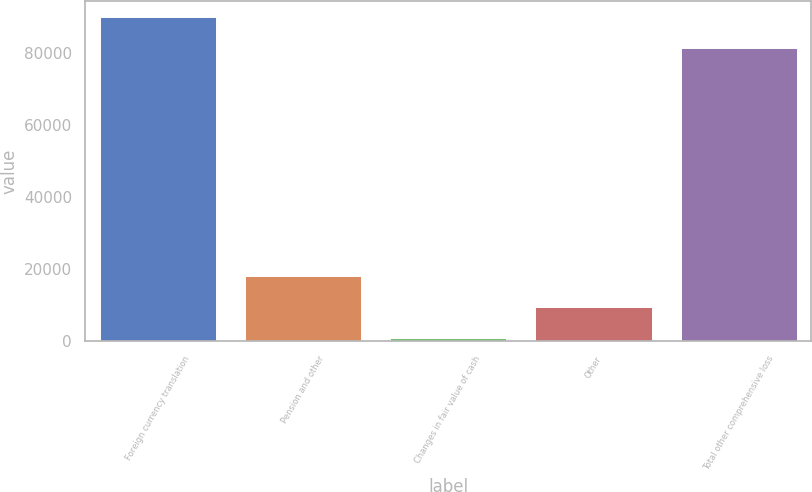Convert chart. <chart><loc_0><loc_0><loc_500><loc_500><bar_chart><fcel>Foreign currency translation<fcel>Pension and other<fcel>Changes in fair value of cash<fcel>Other<fcel>Total other comprehensive loss<nl><fcel>89800.6<fcel>18063.2<fcel>860<fcel>9461.6<fcel>81199<nl></chart> 